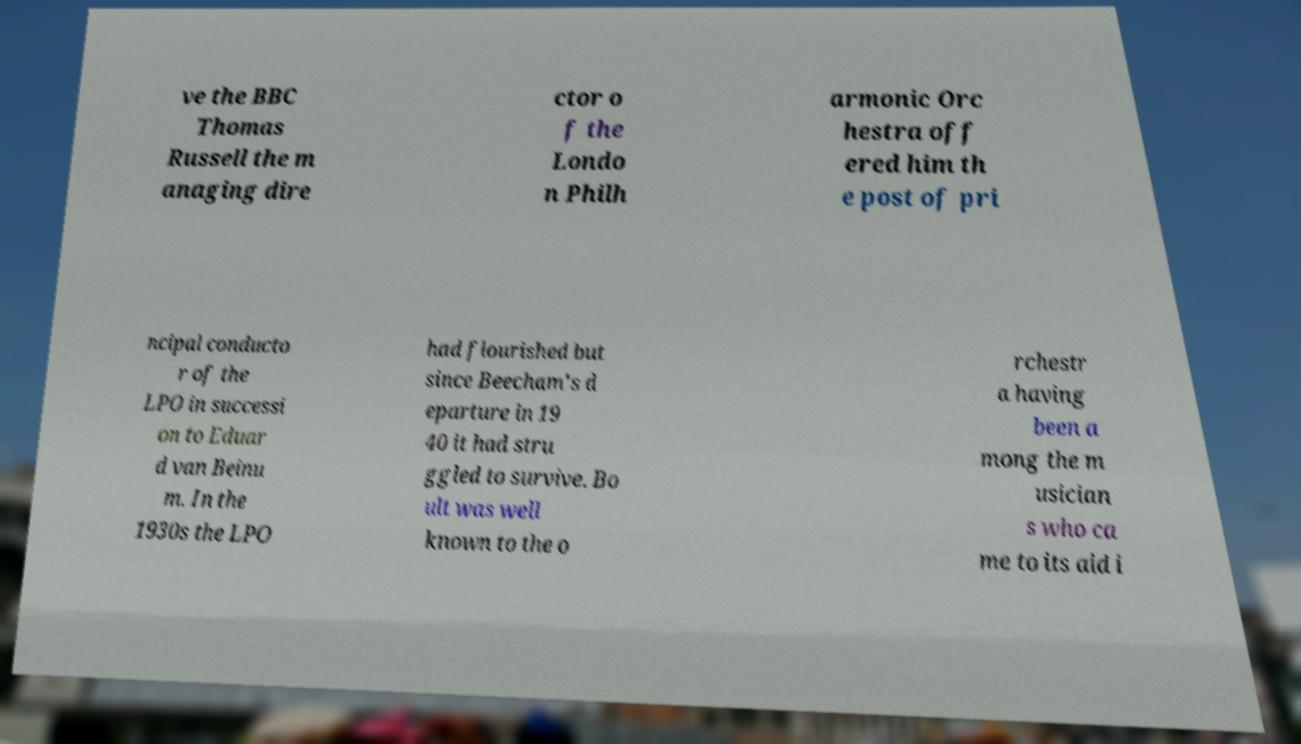Can you read and provide the text displayed in the image?This photo seems to have some interesting text. Can you extract and type it out for me? ve the BBC Thomas Russell the m anaging dire ctor o f the Londo n Philh armonic Orc hestra off ered him th e post of pri ncipal conducto r of the LPO in successi on to Eduar d van Beinu m. In the 1930s the LPO had flourished but since Beecham's d eparture in 19 40 it had stru ggled to survive. Bo ult was well known to the o rchestr a having been a mong the m usician s who ca me to its aid i 